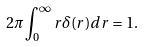<formula> <loc_0><loc_0><loc_500><loc_500>2 \pi \int _ { 0 } ^ { \infty } r \delta ( r ) d r = 1 .</formula> 